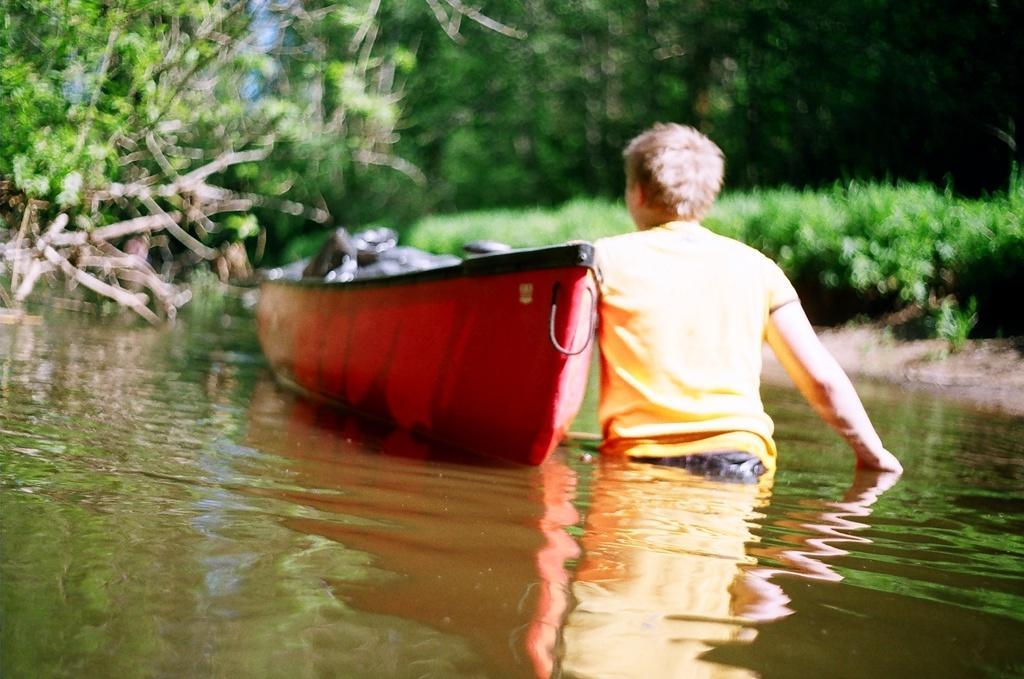How would you summarize this image in a sentence or two? In this image at the bottom there is a river, and in the river there is one boat and one person. And in the background there are some trees and plants. 